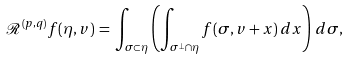<formula> <loc_0><loc_0><loc_500><loc_500>\mathcal { R } ^ { ( p , q ) } f ( \eta , v ) \, = \, \int _ { \sigma \subset \eta } \left ( \int _ { \sigma ^ { \perp } \cap \eta } f ( \sigma , v + x ) \, d x \right ) \, d \sigma ,</formula> 